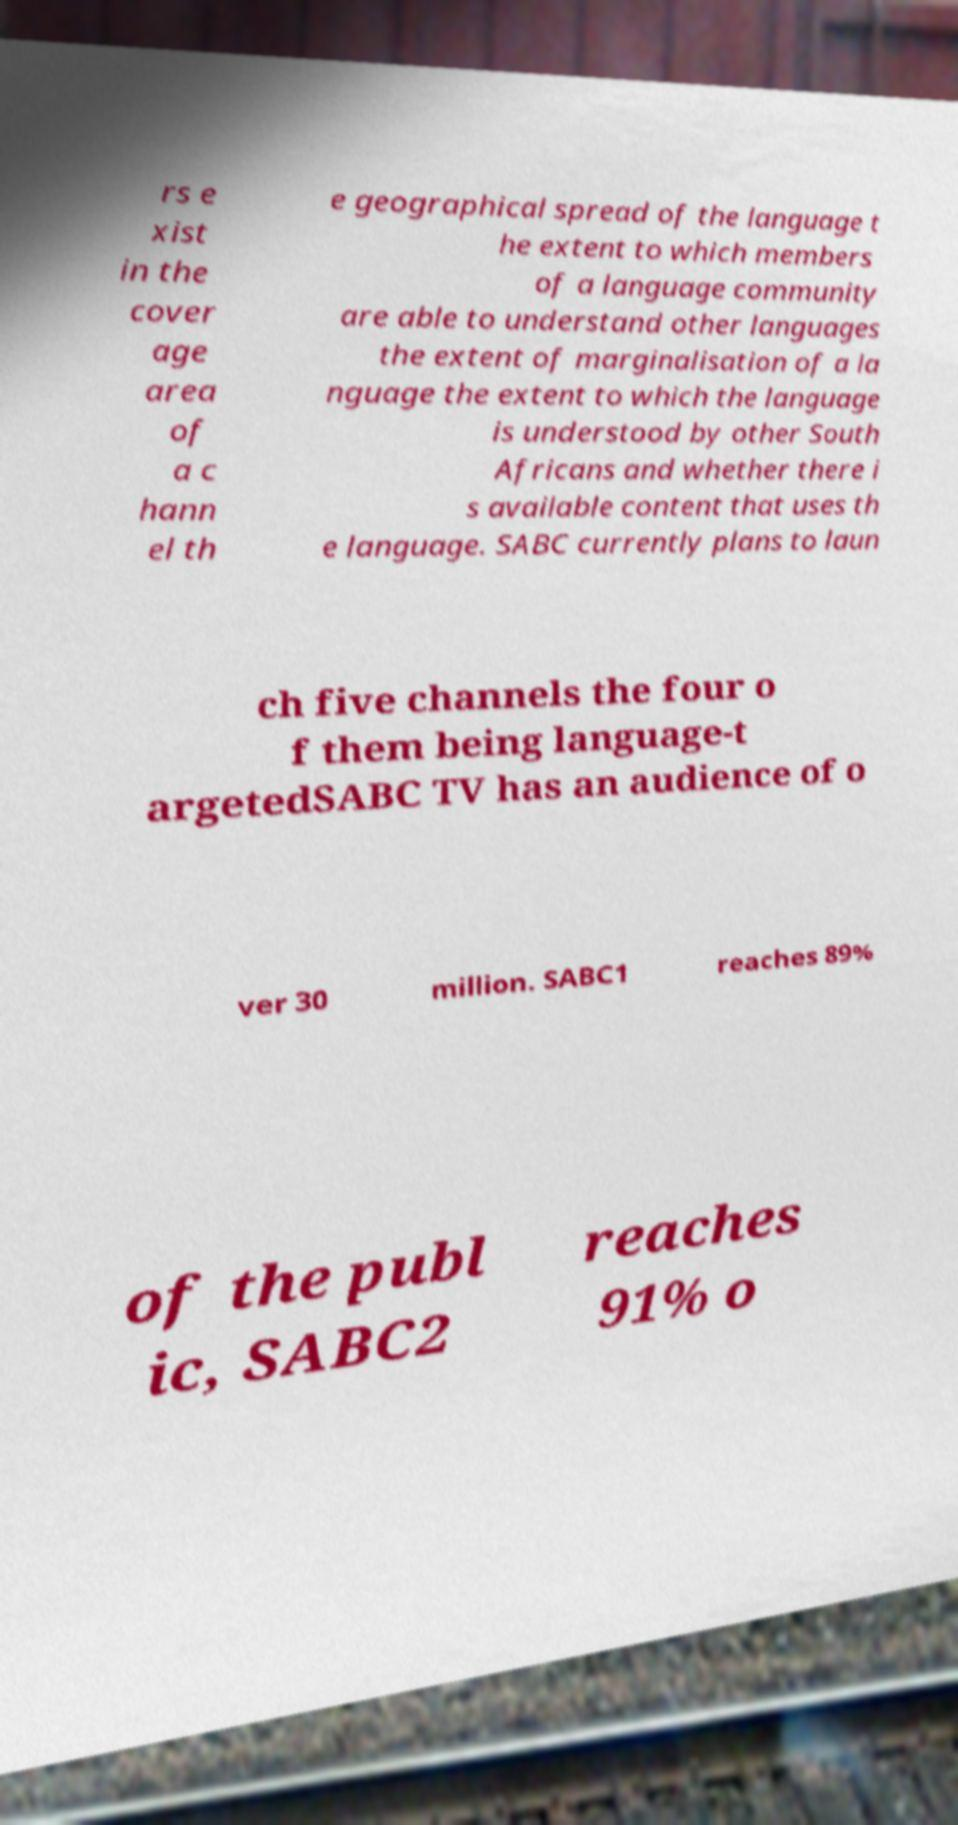I need the written content from this picture converted into text. Can you do that? rs e xist in the cover age area of a c hann el th e geographical spread of the language t he extent to which members of a language community are able to understand other languages the extent of marginalisation of a la nguage the extent to which the language is understood by other South Africans and whether there i s available content that uses th e language. SABC currently plans to laun ch five channels the four o f them being language-t argetedSABC TV has an audience of o ver 30 million. SABC1 reaches 89% of the publ ic, SABC2 reaches 91% o 